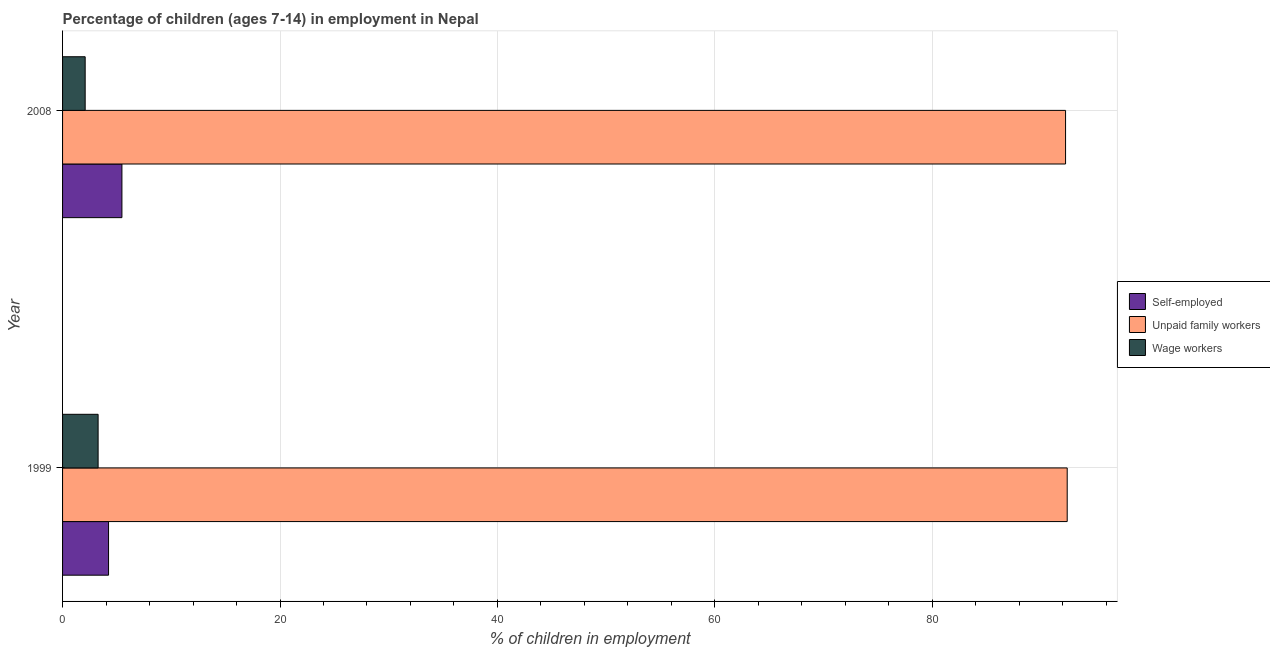How many groups of bars are there?
Provide a short and direct response. 2. Are the number of bars per tick equal to the number of legend labels?
Provide a short and direct response. Yes. Are the number of bars on each tick of the Y-axis equal?
Provide a succinct answer. Yes. How many bars are there on the 2nd tick from the top?
Keep it short and to the point. 3. What is the percentage of children employed as unpaid family workers in 2008?
Your answer should be compact. 92.26. Across all years, what is the maximum percentage of self employed children?
Your response must be concise. 5.46. Across all years, what is the minimum percentage of children employed as unpaid family workers?
Ensure brevity in your answer.  92.26. In which year was the percentage of children employed as wage workers minimum?
Give a very brief answer. 2008. What is the total percentage of children employed as unpaid family workers in the graph?
Your response must be concise. 184.67. What is the difference between the percentage of children employed as wage workers in 1999 and that in 2008?
Your answer should be very brief. 1.19. What is the difference between the percentage of children employed as unpaid family workers in 2008 and the percentage of children employed as wage workers in 1999?
Your response must be concise. 88.99. What is the average percentage of children employed as wage workers per year?
Make the answer very short. 2.67. In the year 2008, what is the difference between the percentage of self employed children and percentage of children employed as wage workers?
Offer a terse response. 3.38. What is the ratio of the percentage of children employed as unpaid family workers in 1999 to that in 2008?
Keep it short and to the point. 1. Is the difference between the percentage of children employed as unpaid family workers in 1999 and 2008 greater than the difference between the percentage of children employed as wage workers in 1999 and 2008?
Give a very brief answer. No. What does the 1st bar from the top in 2008 represents?
Your response must be concise. Wage workers. What does the 3rd bar from the bottom in 1999 represents?
Ensure brevity in your answer.  Wage workers. Is it the case that in every year, the sum of the percentage of self employed children and percentage of children employed as unpaid family workers is greater than the percentage of children employed as wage workers?
Provide a short and direct response. Yes. How many bars are there?
Your answer should be very brief. 6. Are all the bars in the graph horizontal?
Give a very brief answer. Yes. Are the values on the major ticks of X-axis written in scientific E-notation?
Ensure brevity in your answer.  No. Does the graph contain any zero values?
Provide a short and direct response. No. Does the graph contain grids?
Offer a very short reply. Yes. How many legend labels are there?
Ensure brevity in your answer.  3. How are the legend labels stacked?
Make the answer very short. Vertical. What is the title of the graph?
Make the answer very short. Percentage of children (ages 7-14) in employment in Nepal. What is the label or title of the X-axis?
Give a very brief answer. % of children in employment. What is the % of children in employment of Self-employed in 1999?
Provide a succinct answer. 4.23. What is the % of children in employment in Unpaid family workers in 1999?
Your answer should be compact. 92.41. What is the % of children in employment of Wage workers in 1999?
Ensure brevity in your answer.  3.27. What is the % of children in employment of Self-employed in 2008?
Ensure brevity in your answer.  5.46. What is the % of children in employment in Unpaid family workers in 2008?
Provide a succinct answer. 92.26. What is the % of children in employment in Wage workers in 2008?
Your answer should be very brief. 2.08. Across all years, what is the maximum % of children in employment of Self-employed?
Your answer should be very brief. 5.46. Across all years, what is the maximum % of children in employment in Unpaid family workers?
Ensure brevity in your answer.  92.41. Across all years, what is the maximum % of children in employment in Wage workers?
Your answer should be very brief. 3.27. Across all years, what is the minimum % of children in employment in Self-employed?
Your answer should be compact. 4.23. Across all years, what is the minimum % of children in employment of Unpaid family workers?
Keep it short and to the point. 92.26. Across all years, what is the minimum % of children in employment in Wage workers?
Offer a very short reply. 2.08. What is the total % of children in employment in Self-employed in the graph?
Offer a very short reply. 9.69. What is the total % of children in employment in Unpaid family workers in the graph?
Offer a terse response. 184.67. What is the total % of children in employment in Wage workers in the graph?
Give a very brief answer. 5.35. What is the difference between the % of children in employment in Self-employed in 1999 and that in 2008?
Give a very brief answer. -1.23. What is the difference between the % of children in employment of Wage workers in 1999 and that in 2008?
Your answer should be compact. 1.19. What is the difference between the % of children in employment of Self-employed in 1999 and the % of children in employment of Unpaid family workers in 2008?
Ensure brevity in your answer.  -88.03. What is the difference between the % of children in employment in Self-employed in 1999 and the % of children in employment in Wage workers in 2008?
Ensure brevity in your answer.  2.15. What is the difference between the % of children in employment of Unpaid family workers in 1999 and the % of children in employment of Wage workers in 2008?
Provide a short and direct response. 90.33. What is the average % of children in employment of Self-employed per year?
Provide a short and direct response. 4.84. What is the average % of children in employment in Unpaid family workers per year?
Give a very brief answer. 92.33. What is the average % of children in employment in Wage workers per year?
Provide a short and direct response. 2.67. In the year 1999, what is the difference between the % of children in employment of Self-employed and % of children in employment of Unpaid family workers?
Provide a short and direct response. -88.18. In the year 1999, what is the difference between the % of children in employment of Self-employed and % of children in employment of Wage workers?
Give a very brief answer. 0.96. In the year 1999, what is the difference between the % of children in employment in Unpaid family workers and % of children in employment in Wage workers?
Keep it short and to the point. 89.14. In the year 2008, what is the difference between the % of children in employment in Self-employed and % of children in employment in Unpaid family workers?
Your response must be concise. -86.8. In the year 2008, what is the difference between the % of children in employment of Self-employed and % of children in employment of Wage workers?
Make the answer very short. 3.38. In the year 2008, what is the difference between the % of children in employment of Unpaid family workers and % of children in employment of Wage workers?
Make the answer very short. 90.18. What is the ratio of the % of children in employment of Self-employed in 1999 to that in 2008?
Provide a succinct answer. 0.77. What is the ratio of the % of children in employment in Unpaid family workers in 1999 to that in 2008?
Ensure brevity in your answer.  1. What is the ratio of the % of children in employment in Wage workers in 1999 to that in 2008?
Make the answer very short. 1.57. What is the difference between the highest and the second highest % of children in employment of Self-employed?
Keep it short and to the point. 1.23. What is the difference between the highest and the second highest % of children in employment of Wage workers?
Your answer should be compact. 1.19. What is the difference between the highest and the lowest % of children in employment of Self-employed?
Offer a very short reply. 1.23. What is the difference between the highest and the lowest % of children in employment of Unpaid family workers?
Give a very brief answer. 0.15. What is the difference between the highest and the lowest % of children in employment in Wage workers?
Make the answer very short. 1.19. 